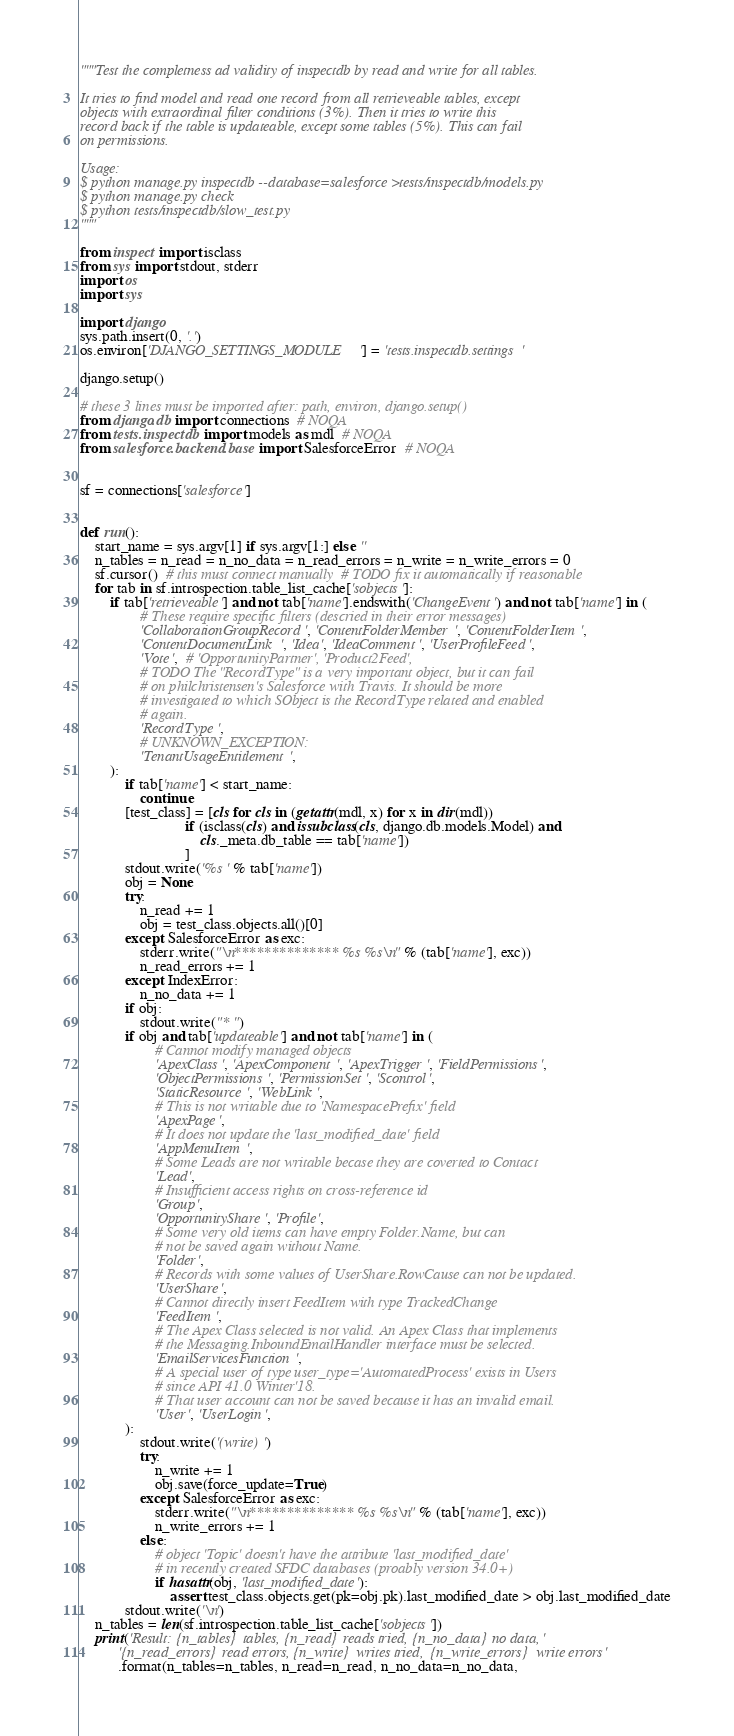Convert code to text. <code><loc_0><loc_0><loc_500><loc_500><_Python_>"""Test the completness ad validity of inspectdb by read and write for all tables.

It tries to find model and read one record from all retrieveable tables, except
objects with extraordinal filter conditions (3%). Then it tries to write this
record back if the table is updateable, except some tables (5%). This can fail
on permissions.

Usage:
$ python manage.py inspectdb --database=salesforce >tests/inspectdb/models.py
$ python manage.py check
$ python tests/inspectdb/slow_test.py
"""

from inspect import isclass
from sys import stdout, stderr
import os
import sys

import django
sys.path.insert(0, '.')
os.environ['DJANGO_SETTINGS_MODULE'] = 'tests.inspectdb.settings'

django.setup()

# these 3 lines must be imported after: path, environ, django.setup()
from django.db import connections  # NOQA
from tests.inspectdb import models as mdl  # NOQA
from salesforce.backend.base import SalesforceError  # NOQA


sf = connections['salesforce']


def run():
    start_name = sys.argv[1] if sys.argv[1:] else ''
    n_tables = n_read = n_no_data = n_read_errors = n_write = n_write_errors = 0
    sf.cursor()  # this must connect manually  # TODO fix it automatically if reasonable
    for tab in sf.introspection.table_list_cache['sobjects']:
        if tab['retrieveable'] and not tab['name'].endswith('ChangeEvent') and not tab['name'] in (
                # These require specific filters (descried in their error messages)
                'CollaborationGroupRecord', 'ContentFolderMember', 'ContentFolderItem',
                'ContentDocumentLink', 'Idea', 'IdeaComment', 'UserProfileFeed',
                'Vote',  # 'OpportunityPartner', 'Product2Feed',
                # TODO The "RecordType" is a very important object, but it can fail
                # on philchristensen's Salesforce with Travis. It should be more
                # investigated to which SObject is the RecordType related and enabled
                # again.
                'RecordType',
                # UNKNOWN_EXCEPTION:
                'TenantUsageEntitlement',
        ):
            if tab['name'] < start_name:
                continue
            [test_class] = [cls for cls in (getattr(mdl, x) for x in dir(mdl))
                            if (isclass(cls) and issubclass(cls, django.db.models.Model) and
                                cls._meta.db_table == tab['name'])
                            ]
            stdout.write('%s ' % tab['name'])
            obj = None
            try:
                n_read += 1
                obj = test_class.objects.all()[0]
            except SalesforceError as exc:
                stderr.write("\n************** %s %s\n" % (tab['name'], exc))
                n_read_errors += 1
            except IndexError:
                n_no_data += 1
            if obj:
                stdout.write("* ")
            if obj and tab['updateable'] and not tab['name'] in (
                    # Cannot modify managed objects
                    'ApexClass', 'ApexComponent', 'ApexTrigger', 'FieldPermissions',
                    'ObjectPermissions', 'PermissionSet', 'Scontrol',
                    'StaticResource', 'WebLink',
                    # This is not writable due to 'NamespacePrefix' field
                    'ApexPage',
                    # It does not update the 'last_modified_date' field
                    'AppMenuItem',
                    # Some Leads are not writable becase they are coverted to Contact
                    'Lead',
                    # Insufficient access rights on cross-reference id
                    'Group',
                    'OpportunityShare', 'Profile',
                    # Some very old items can have empty Folder.Name, but can
                    # not be saved again without Name.
                    'Folder',
                    # Records with some values of UserShare.RowCause can not be updated.
                    'UserShare',
                    # Cannot directly insert FeedItem with type TrackedChange
                    'FeedItem',
                    # The Apex Class selected is not valid. An Apex Class that implements
                    # the Messaging.InboundEmailHandler interface must be selected.
                    'EmailServicesFunction',
                    # A special user of type user_type='AutomatedProcess' exists in Users
                    # since API 41.0 Winter'18.
                    # That user account can not be saved because it has an invalid email.
                    'User', 'UserLogin',
            ):
                stdout.write('(write) ')
                try:
                    n_write += 1
                    obj.save(force_update=True)
                except SalesforceError as exc:
                    stderr.write("\n************** %s %s\n" % (tab['name'], exc))
                    n_write_errors += 1
                else:
                    # object 'Topic' doesn't have the attribute 'last_modified_date'
                    # in recently created SFDC databases (proably version 34.0+)
                    if hasattr(obj, 'last_modified_date'):
                        assert test_class.objects.get(pk=obj.pk).last_modified_date > obj.last_modified_date
            stdout.write('\n')
    n_tables = len(sf.introspection.table_list_cache['sobjects'])
    print('Result: {n_tables} tables, {n_read} reads tried, {n_no_data} no data, '
          '{n_read_errors} read errors, {n_write} writes tried, {n_write_errors} write errors'
          .format(n_tables=n_tables, n_read=n_read, n_no_data=n_no_data,</code> 